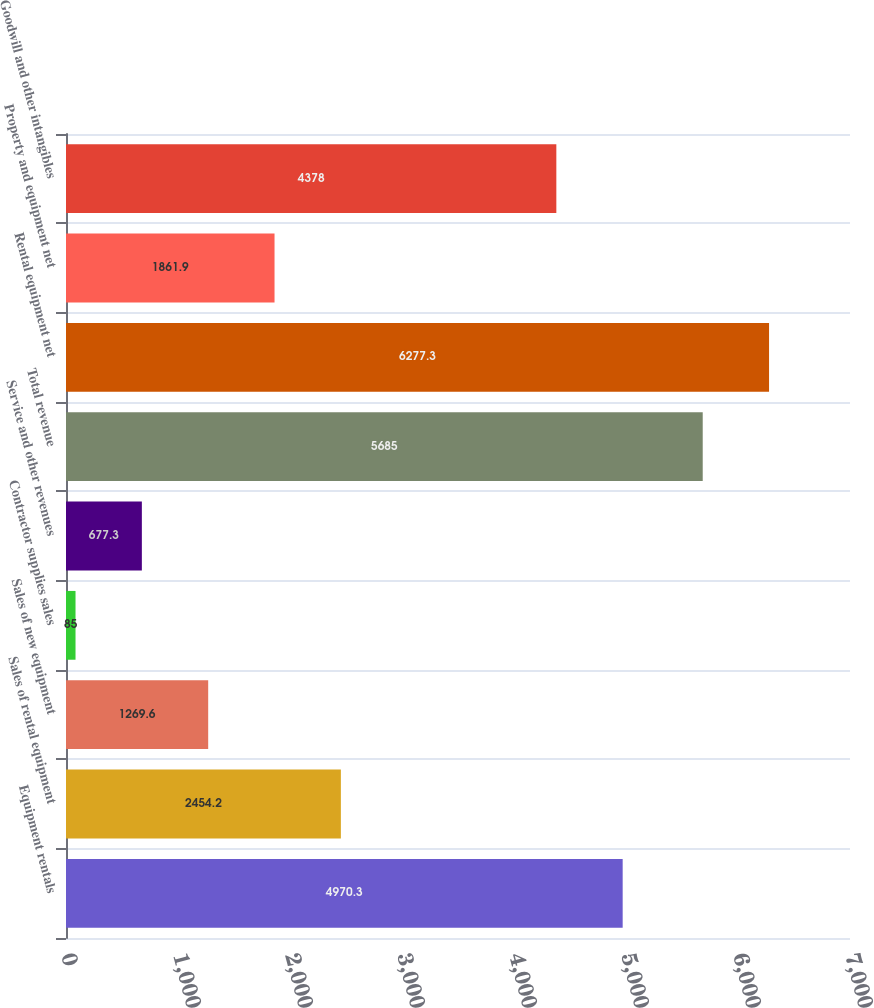Convert chart. <chart><loc_0><loc_0><loc_500><loc_500><bar_chart><fcel>Equipment rentals<fcel>Sales of rental equipment<fcel>Sales of new equipment<fcel>Contractor supplies sales<fcel>Service and other revenues<fcel>Total revenue<fcel>Rental equipment net<fcel>Property and equipment net<fcel>Goodwill and other intangibles<nl><fcel>4970.3<fcel>2454.2<fcel>1269.6<fcel>85<fcel>677.3<fcel>5685<fcel>6277.3<fcel>1861.9<fcel>4378<nl></chart> 